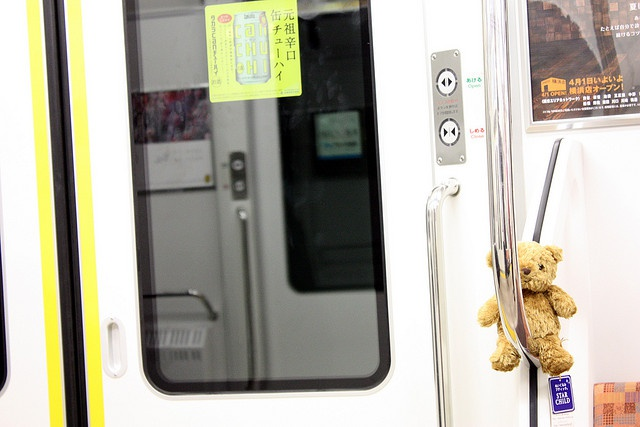Describe the objects in this image and their specific colors. I can see a teddy bear in white, tan, khaki, ivory, and olive tones in this image. 